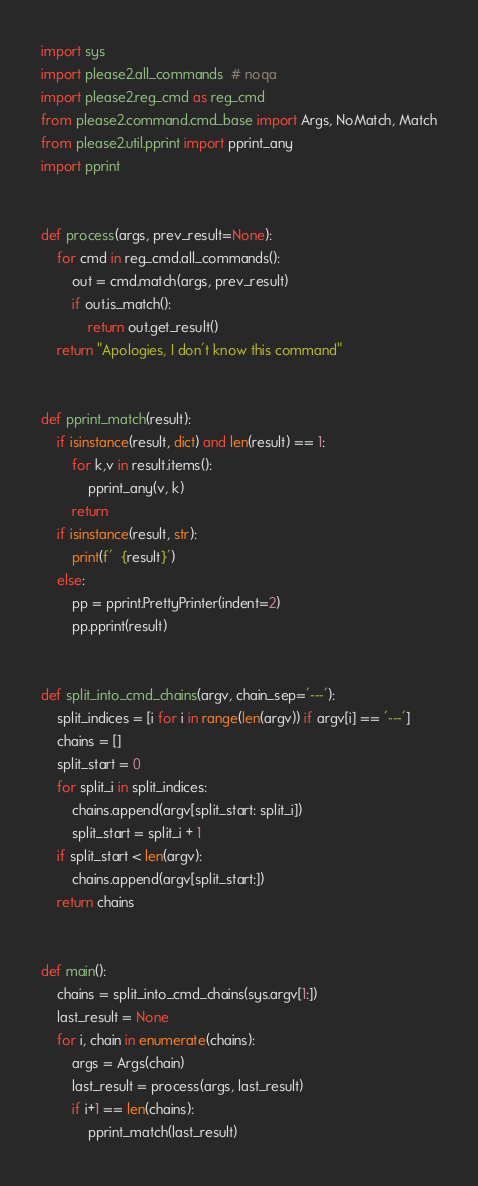Convert code to text. <code><loc_0><loc_0><loc_500><loc_500><_Python_>import sys
import please2.all_commands  # noqa
import please2.reg_cmd as reg_cmd
from please2.command.cmd_base import Args, NoMatch, Match
from please2.util.pprint import pprint_any
import pprint


def process(args, prev_result=None):
    for cmd in reg_cmd.all_commands():
        out = cmd.match(args, prev_result)
        if out.is_match():
            return out.get_result()
    return "Apologies, I don't know this command"


def pprint_match(result):
    if isinstance(result, dict) and len(result) == 1:
        for k,v in result.items():
            pprint_any(v, k)
        return
    if isinstance(result, str):
        print(f'  {result}')
    else:
        pp = pprint.PrettyPrinter(indent=2)
        pp.pprint(result)


def split_into_cmd_chains(argv, chain_sep='---'):
    split_indices = [i for i in range(len(argv)) if argv[i] == '---']
    chains = []
    split_start = 0
    for split_i in split_indices:
        chains.append(argv[split_start: split_i])
        split_start = split_i + 1
    if split_start < len(argv):
        chains.append(argv[split_start:])
    return chains


def main():
    chains = split_into_cmd_chains(sys.argv[1:])
    last_result = None
    for i, chain in enumerate(chains):
        args = Args(chain)
        last_result = process(args, last_result)
        if i+1 == len(chains):
            pprint_match(last_result)
</code> 